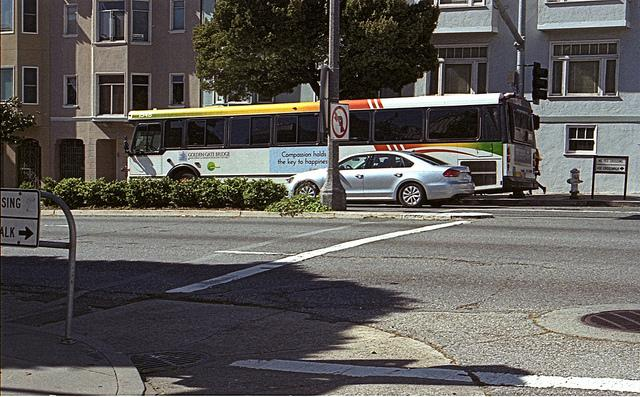What is the car next to?

Choices:
A) elephant
B) airplane
C) bus
D) giraffe bus 